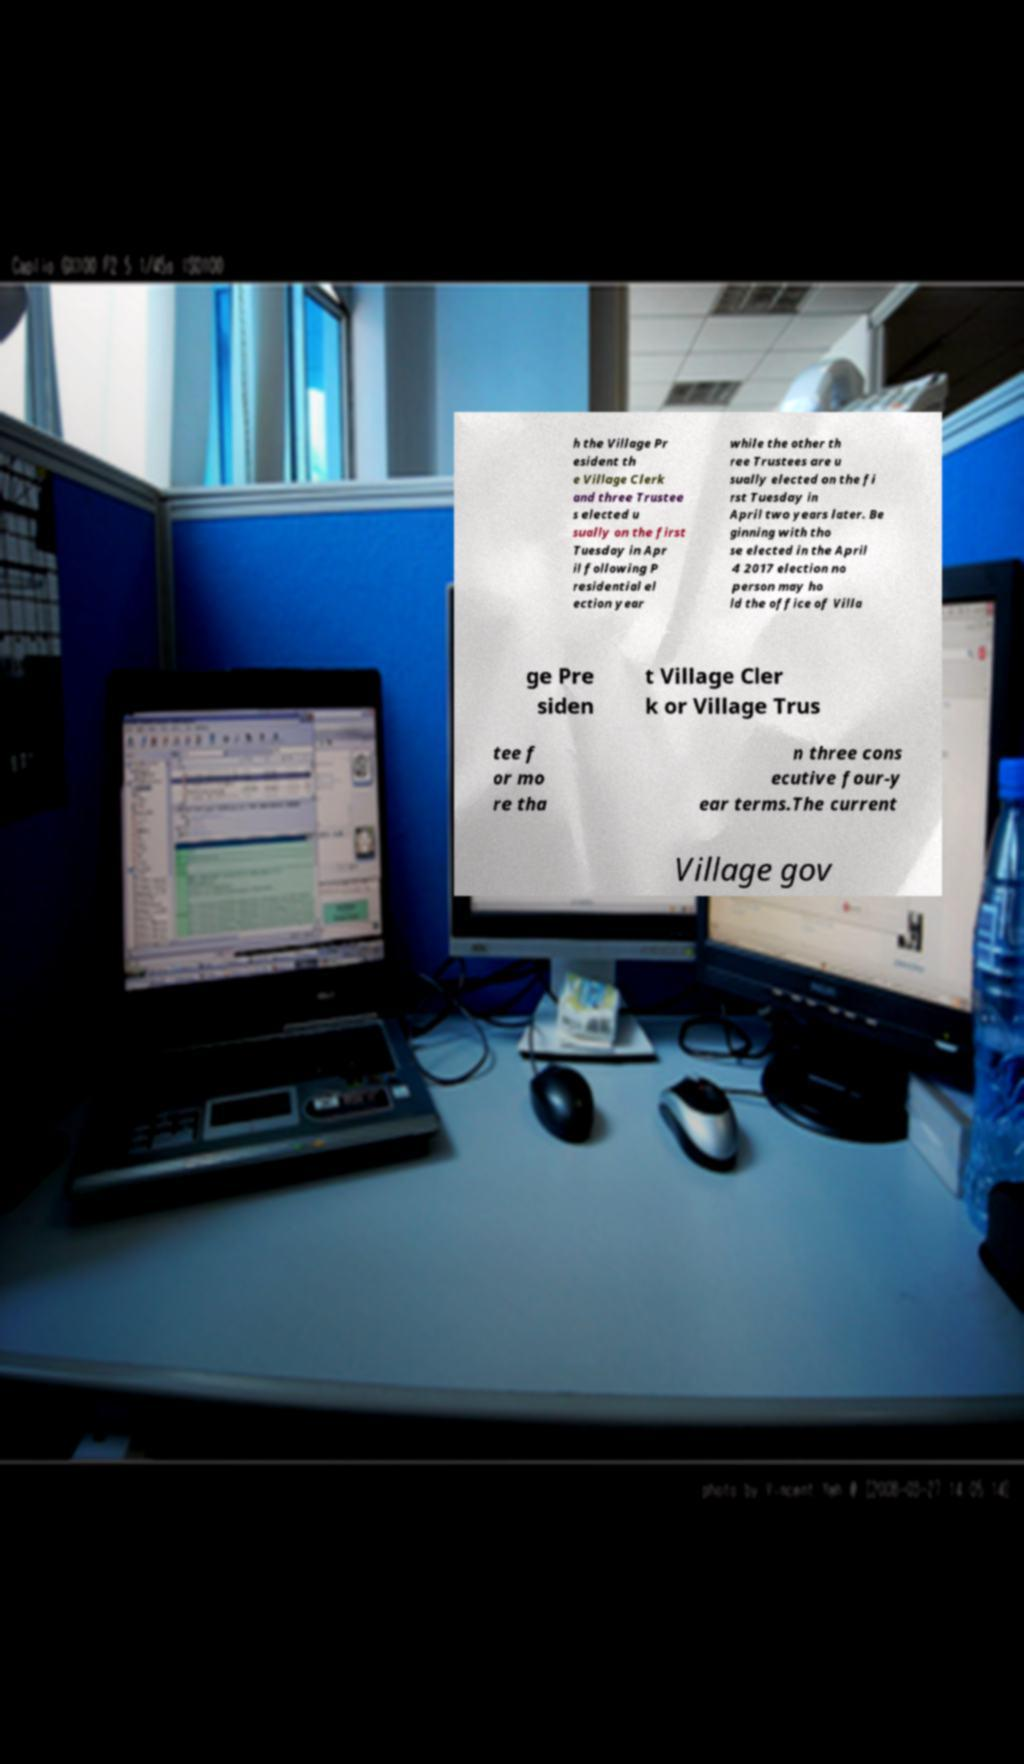Can you accurately transcribe the text from the provided image for me? h the Village Pr esident th e Village Clerk and three Trustee s elected u sually on the first Tuesday in Apr il following P residential el ection year while the other th ree Trustees are u sually elected on the fi rst Tuesday in April two years later. Be ginning with tho se elected in the April 4 2017 election no person may ho ld the office of Villa ge Pre siden t Village Cler k or Village Trus tee f or mo re tha n three cons ecutive four-y ear terms.The current Village gov 